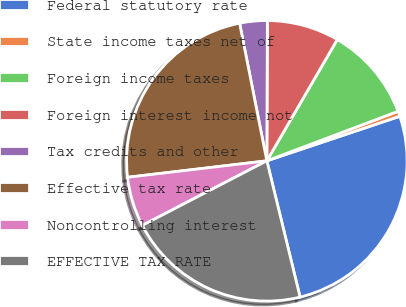Convert chart. <chart><loc_0><loc_0><loc_500><loc_500><pie_chart><fcel>Federal statutory rate<fcel>State income taxes net of<fcel>Foreign income taxes<fcel>Foreign interest income not<fcel>Tax credits and other<fcel>Effective tax rate<fcel>Noncontrolling interest<fcel>EFFECTIVE TAX RATE<nl><fcel>26.33%<fcel>0.6%<fcel>10.88%<fcel>8.31%<fcel>3.17%<fcel>23.76%<fcel>5.74%<fcel>21.19%<nl></chart> 